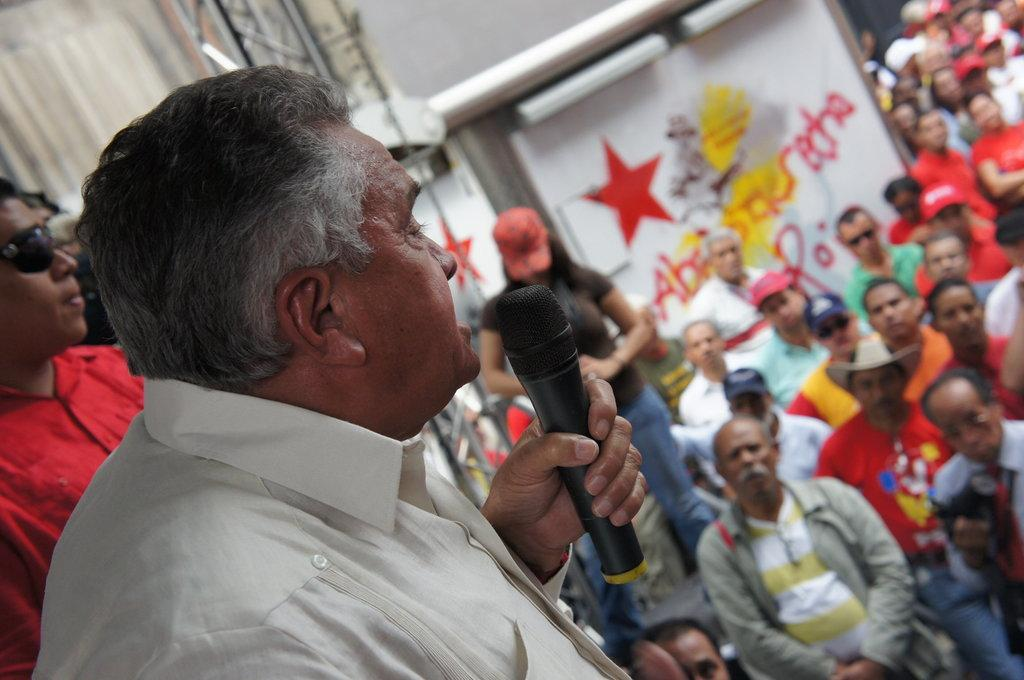What is the man in the image holding? The man is holding a microphone in the image. Who else is present in the image besides the man with the microphone? There is a group of people in the image. What type of structure can be seen in the image? There is a truss in the image. What can be seen in the background of the image? There are objects visible in the background of the image. Where is the creator's nest located in the image? There is no mention of a creator or a nest in the image. The image features a man holding a microphone, a group of people, a truss, and background objects. 